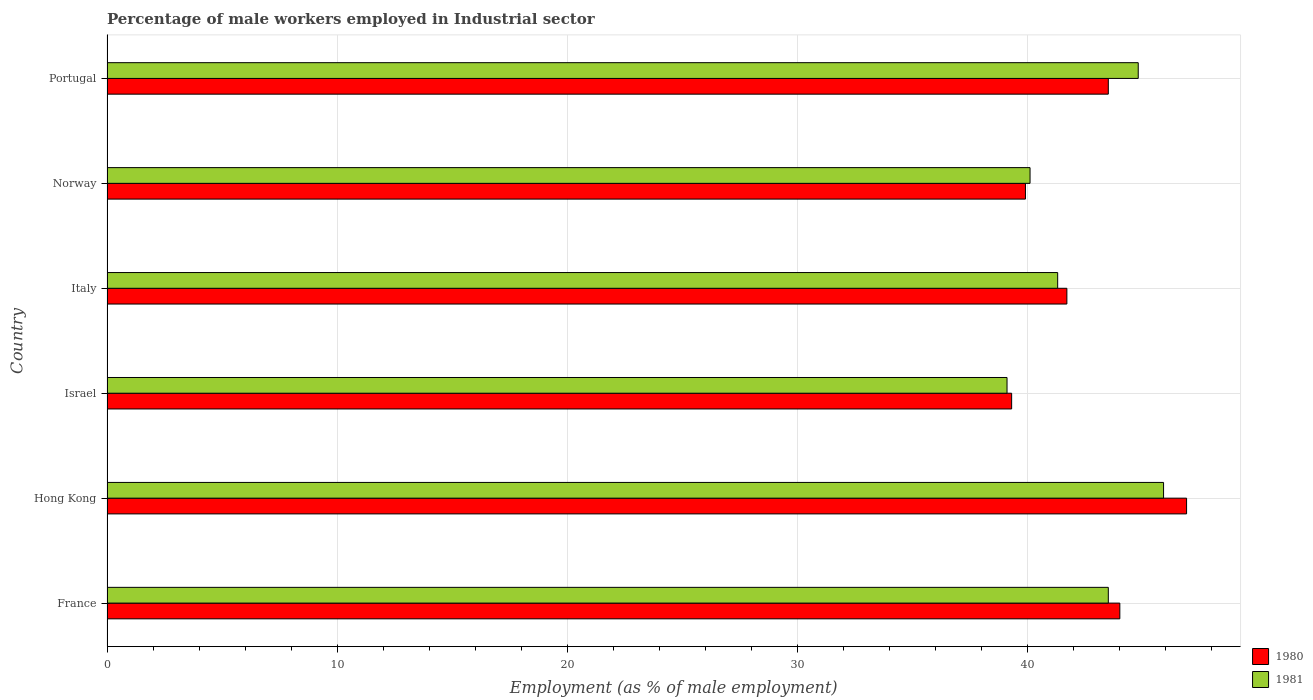How many different coloured bars are there?
Your answer should be compact. 2. Are the number of bars per tick equal to the number of legend labels?
Make the answer very short. Yes. How many bars are there on the 2nd tick from the top?
Give a very brief answer. 2. What is the percentage of male workers employed in Industrial sector in 1980 in Portugal?
Give a very brief answer. 43.5. Across all countries, what is the maximum percentage of male workers employed in Industrial sector in 1980?
Your response must be concise. 46.9. Across all countries, what is the minimum percentage of male workers employed in Industrial sector in 1981?
Your answer should be compact. 39.1. In which country was the percentage of male workers employed in Industrial sector in 1980 maximum?
Your answer should be very brief. Hong Kong. In which country was the percentage of male workers employed in Industrial sector in 1980 minimum?
Offer a very short reply. Israel. What is the total percentage of male workers employed in Industrial sector in 1980 in the graph?
Your answer should be compact. 255.3. What is the difference between the percentage of male workers employed in Industrial sector in 1980 in Hong Kong and that in Norway?
Provide a succinct answer. 7. What is the difference between the percentage of male workers employed in Industrial sector in 1981 in Hong Kong and the percentage of male workers employed in Industrial sector in 1980 in Norway?
Keep it short and to the point. 6. What is the average percentage of male workers employed in Industrial sector in 1980 per country?
Your answer should be very brief. 42.55. What is the difference between the percentage of male workers employed in Industrial sector in 1981 and percentage of male workers employed in Industrial sector in 1980 in Portugal?
Ensure brevity in your answer.  1.3. What is the ratio of the percentage of male workers employed in Industrial sector in 1981 in France to that in Portugal?
Offer a terse response. 0.97. Is the percentage of male workers employed in Industrial sector in 1981 in Italy less than that in Portugal?
Give a very brief answer. Yes. What is the difference between the highest and the second highest percentage of male workers employed in Industrial sector in 1980?
Ensure brevity in your answer.  2.9. What is the difference between the highest and the lowest percentage of male workers employed in Industrial sector in 1980?
Provide a short and direct response. 7.6. In how many countries, is the percentage of male workers employed in Industrial sector in 1980 greater than the average percentage of male workers employed in Industrial sector in 1980 taken over all countries?
Give a very brief answer. 3. What does the 2nd bar from the bottom in Norway represents?
Ensure brevity in your answer.  1981. How many bars are there?
Offer a terse response. 12. Are all the bars in the graph horizontal?
Offer a very short reply. Yes. How many countries are there in the graph?
Offer a terse response. 6. What is the difference between two consecutive major ticks on the X-axis?
Your response must be concise. 10. Does the graph contain any zero values?
Provide a succinct answer. No. Where does the legend appear in the graph?
Give a very brief answer. Bottom right. How many legend labels are there?
Give a very brief answer. 2. What is the title of the graph?
Ensure brevity in your answer.  Percentage of male workers employed in Industrial sector. What is the label or title of the X-axis?
Provide a short and direct response. Employment (as % of male employment). What is the label or title of the Y-axis?
Your answer should be very brief. Country. What is the Employment (as % of male employment) in 1981 in France?
Your response must be concise. 43.5. What is the Employment (as % of male employment) of 1980 in Hong Kong?
Make the answer very short. 46.9. What is the Employment (as % of male employment) of 1981 in Hong Kong?
Provide a short and direct response. 45.9. What is the Employment (as % of male employment) in 1980 in Israel?
Keep it short and to the point. 39.3. What is the Employment (as % of male employment) of 1981 in Israel?
Your answer should be very brief. 39.1. What is the Employment (as % of male employment) of 1980 in Italy?
Your answer should be compact. 41.7. What is the Employment (as % of male employment) of 1981 in Italy?
Your answer should be very brief. 41.3. What is the Employment (as % of male employment) in 1980 in Norway?
Give a very brief answer. 39.9. What is the Employment (as % of male employment) in 1981 in Norway?
Your response must be concise. 40.1. What is the Employment (as % of male employment) of 1980 in Portugal?
Your response must be concise. 43.5. What is the Employment (as % of male employment) of 1981 in Portugal?
Provide a short and direct response. 44.8. Across all countries, what is the maximum Employment (as % of male employment) of 1980?
Make the answer very short. 46.9. Across all countries, what is the maximum Employment (as % of male employment) in 1981?
Provide a short and direct response. 45.9. Across all countries, what is the minimum Employment (as % of male employment) of 1980?
Provide a succinct answer. 39.3. Across all countries, what is the minimum Employment (as % of male employment) in 1981?
Your response must be concise. 39.1. What is the total Employment (as % of male employment) in 1980 in the graph?
Your answer should be compact. 255.3. What is the total Employment (as % of male employment) of 1981 in the graph?
Make the answer very short. 254.7. What is the difference between the Employment (as % of male employment) in 1980 in France and that in Israel?
Make the answer very short. 4.7. What is the difference between the Employment (as % of male employment) in 1981 in France and that in Israel?
Offer a very short reply. 4.4. What is the difference between the Employment (as % of male employment) of 1980 in France and that in Italy?
Keep it short and to the point. 2.3. What is the difference between the Employment (as % of male employment) of 1980 in France and that in Norway?
Provide a succinct answer. 4.1. What is the difference between the Employment (as % of male employment) of 1981 in France and that in Portugal?
Keep it short and to the point. -1.3. What is the difference between the Employment (as % of male employment) of 1980 in Hong Kong and that in Italy?
Provide a succinct answer. 5.2. What is the difference between the Employment (as % of male employment) in 1981 in Hong Kong and that in Italy?
Make the answer very short. 4.6. What is the difference between the Employment (as % of male employment) in 1980 in Hong Kong and that in Portugal?
Your answer should be very brief. 3.4. What is the difference between the Employment (as % of male employment) in 1980 in Israel and that in Italy?
Ensure brevity in your answer.  -2.4. What is the difference between the Employment (as % of male employment) of 1981 in Israel and that in Italy?
Ensure brevity in your answer.  -2.2. What is the difference between the Employment (as % of male employment) of 1980 in Israel and that in Portugal?
Make the answer very short. -4.2. What is the difference between the Employment (as % of male employment) of 1981 in Israel and that in Portugal?
Provide a succinct answer. -5.7. What is the difference between the Employment (as % of male employment) in 1980 in Italy and that in Portugal?
Your response must be concise. -1.8. What is the difference between the Employment (as % of male employment) of 1981 in Italy and that in Portugal?
Your response must be concise. -3.5. What is the difference between the Employment (as % of male employment) in 1981 in Norway and that in Portugal?
Make the answer very short. -4.7. What is the difference between the Employment (as % of male employment) in 1980 in France and the Employment (as % of male employment) in 1981 in Hong Kong?
Your answer should be very brief. -1.9. What is the difference between the Employment (as % of male employment) in 1980 in Hong Kong and the Employment (as % of male employment) in 1981 in Israel?
Offer a terse response. 7.8. What is the difference between the Employment (as % of male employment) of 1980 in Hong Kong and the Employment (as % of male employment) of 1981 in Italy?
Your answer should be very brief. 5.6. What is the difference between the Employment (as % of male employment) in 1980 in Israel and the Employment (as % of male employment) in 1981 in Italy?
Your answer should be compact. -2. What is the difference between the Employment (as % of male employment) of 1980 in Israel and the Employment (as % of male employment) of 1981 in Norway?
Your answer should be very brief. -0.8. What is the difference between the Employment (as % of male employment) of 1980 in Italy and the Employment (as % of male employment) of 1981 in Norway?
Offer a very short reply. 1.6. What is the average Employment (as % of male employment) of 1980 per country?
Your answer should be compact. 42.55. What is the average Employment (as % of male employment) of 1981 per country?
Make the answer very short. 42.45. What is the difference between the Employment (as % of male employment) of 1980 and Employment (as % of male employment) of 1981 in France?
Ensure brevity in your answer.  0.5. What is the difference between the Employment (as % of male employment) in 1980 and Employment (as % of male employment) in 1981 in Italy?
Offer a very short reply. 0.4. What is the difference between the Employment (as % of male employment) of 1980 and Employment (as % of male employment) of 1981 in Norway?
Provide a succinct answer. -0.2. What is the ratio of the Employment (as % of male employment) in 1980 in France to that in Hong Kong?
Provide a short and direct response. 0.94. What is the ratio of the Employment (as % of male employment) in 1981 in France to that in Hong Kong?
Your answer should be very brief. 0.95. What is the ratio of the Employment (as % of male employment) of 1980 in France to that in Israel?
Your answer should be compact. 1.12. What is the ratio of the Employment (as % of male employment) in 1981 in France to that in Israel?
Offer a very short reply. 1.11. What is the ratio of the Employment (as % of male employment) in 1980 in France to that in Italy?
Make the answer very short. 1.06. What is the ratio of the Employment (as % of male employment) of 1981 in France to that in Italy?
Your response must be concise. 1.05. What is the ratio of the Employment (as % of male employment) in 1980 in France to that in Norway?
Offer a terse response. 1.1. What is the ratio of the Employment (as % of male employment) of 1981 in France to that in Norway?
Your answer should be compact. 1.08. What is the ratio of the Employment (as % of male employment) in 1980 in France to that in Portugal?
Make the answer very short. 1.01. What is the ratio of the Employment (as % of male employment) in 1980 in Hong Kong to that in Israel?
Make the answer very short. 1.19. What is the ratio of the Employment (as % of male employment) in 1981 in Hong Kong to that in Israel?
Provide a succinct answer. 1.17. What is the ratio of the Employment (as % of male employment) of 1980 in Hong Kong to that in Italy?
Your answer should be compact. 1.12. What is the ratio of the Employment (as % of male employment) in 1981 in Hong Kong to that in Italy?
Keep it short and to the point. 1.11. What is the ratio of the Employment (as % of male employment) in 1980 in Hong Kong to that in Norway?
Keep it short and to the point. 1.18. What is the ratio of the Employment (as % of male employment) of 1981 in Hong Kong to that in Norway?
Your response must be concise. 1.14. What is the ratio of the Employment (as % of male employment) in 1980 in Hong Kong to that in Portugal?
Provide a succinct answer. 1.08. What is the ratio of the Employment (as % of male employment) of 1981 in Hong Kong to that in Portugal?
Keep it short and to the point. 1.02. What is the ratio of the Employment (as % of male employment) of 1980 in Israel to that in Italy?
Keep it short and to the point. 0.94. What is the ratio of the Employment (as % of male employment) in 1981 in Israel to that in Italy?
Ensure brevity in your answer.  0.95. What is the ratio of the Employment (as % of male employment) in 1980 in Israel to that in Norway?
Ensure brevity in your answer.  0.98. What is the ratio of the Employment (as % of male employment) in 1981 in Israel to that in Norway?
Provide a succinct answer. 0.98. What is the ratio of the Employment (as % of male employment) in 1980 in Israel to that in Portugal?
Your response must be concise. 0.9. What is the ratio of the Employment (as % of male employment) of 1981 in Israel to that in Portugal?
Ensure brevity in your answer.  0.87. What is the ratio of the Employment (as % of male employment) of 1980 in Italy to that in Norway?
Keep it short and to the point. 1.05. What is the ratio of the Employment (as % of male employment) of 1981 in Italy to that in Norway?
Your response must be concise. 1.03. What is the ratio of the Employment (as % of male employment) of 1980 in Italy to that in Portugal?
Give a very brief answer. 0.96. What is the ratio of the Employment (as % of male employment) in 1981 in Italy to that in Portugal?
Ensure brevity in your answer.  0.92. What is the ratio of the Employment (as % of male employment) of 1980 in Norway to that in Portugal?
Provide a succinct answer. 0.92. What is the ratio of the Employment (as % of male employment) of 1981 in Norway to that in Portugal?
Make the answer very short. 0.9. What is the difference between the highest and the second highest Employment (as % of male employment) in 1980?
Provide a succinct answer. 2.9. What is the difference between the highest and the second highest Employment (as % of male employment) in 1981?
Provide a short and direct response. 1.1. What is the difference between the highest and the lowest Employment (as % of male employment) of 1981?
Ensure brevity in your answer.  6.8. 